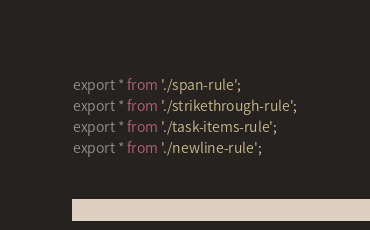<code> <loc_0><loc_0><loc_500><loc_500><_TypeScript_>export * from './span-rule';
export * from './strikethrough-rule';
export * from './task-items-rule';
export * from './newline-rule';</code> 